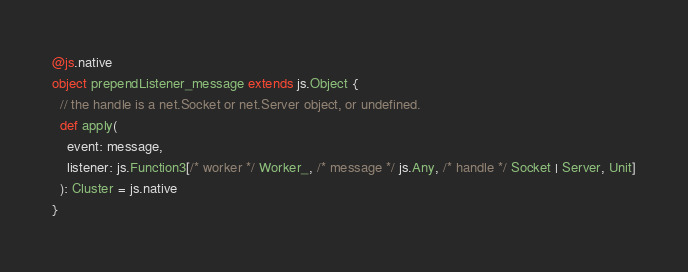<code> <loc_0><loc_0><loc_500><loc_500><_Scala_>@js.native
object prependListener_message extends js.Object {
  // the handle is a net.Socket or net.Server object, or undefined.
  def apply(
    event: message,
    listener: js.Function3[/* worker */ Worker_, /* message */ js.Any, /* handle */ Socket | Server, Unit]
  ): Cluster = js.native
}

</code> 